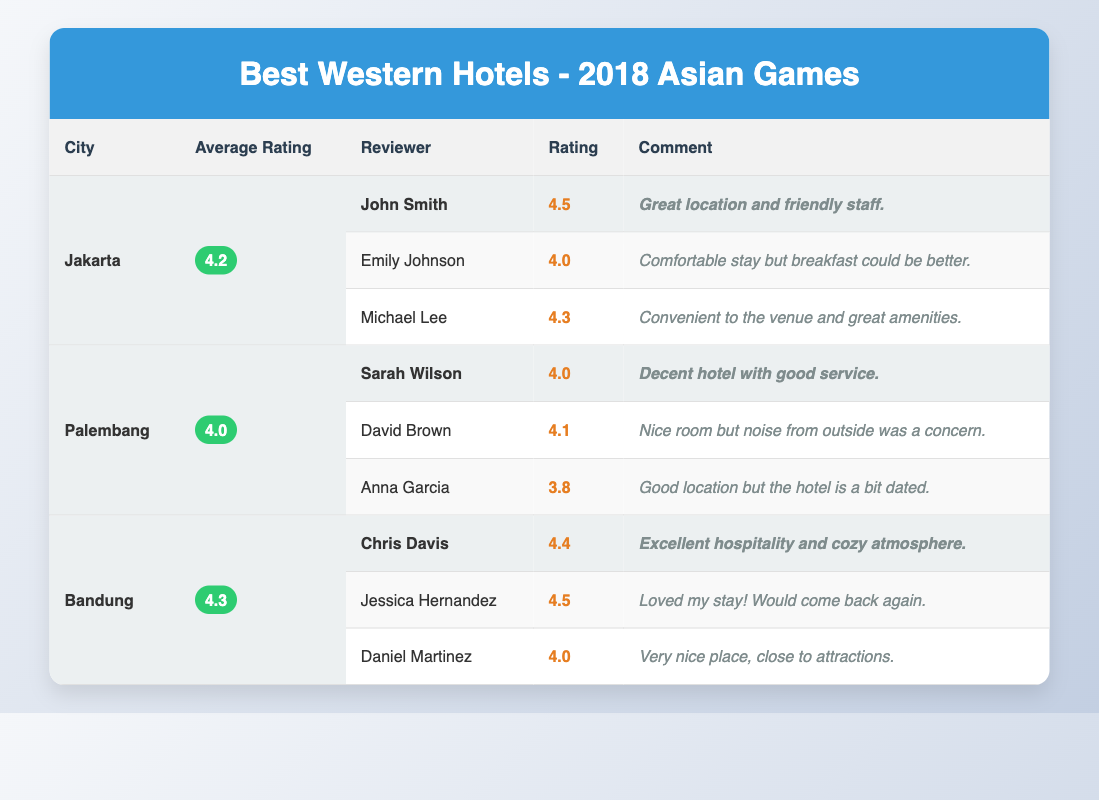What is the average rating for Best Western hotels in Jakarta? The table shows that Jakarta has an average rating of 4.2. This value is directly listed under the "Average Rating" column for Jakarta.
Answer: 4.2 Which city has the highest average rating among the listed Best Western hotels? By comparing the average ratings: Jakarta has 4.2, Palembang has 4.0, and Bandung has 4.3. Therefore, Bandung has the highest average rating of 4.3.
Answer: Bandung Did any reviewer give a rating of 4.5? Upon inspecting the "Rating" column, John Smith and Jessica Hernandez both rated their stays at 4.5. Thus, the answer is yes.
Answer: Yes What is the average rating of all the hotels listed? The average rating is calculated by summing the average ratings: (4.2 + 4.0 + 4.3) = 12.5. Then we divide by the number of cities, which is 3: 12.5 / 3 = 4.17. Therefore, the average rating is approximately 4.17.
Answer: 4.17 How many reviews mention the words "good" or "great"? We can scan through the comments for the terms "good" and "great". The comments of John Smith, Sarah Wilson, Michael Lee, and Chris Davis all use these terms positively, making a total of 4 mentions.
Answer: 4 